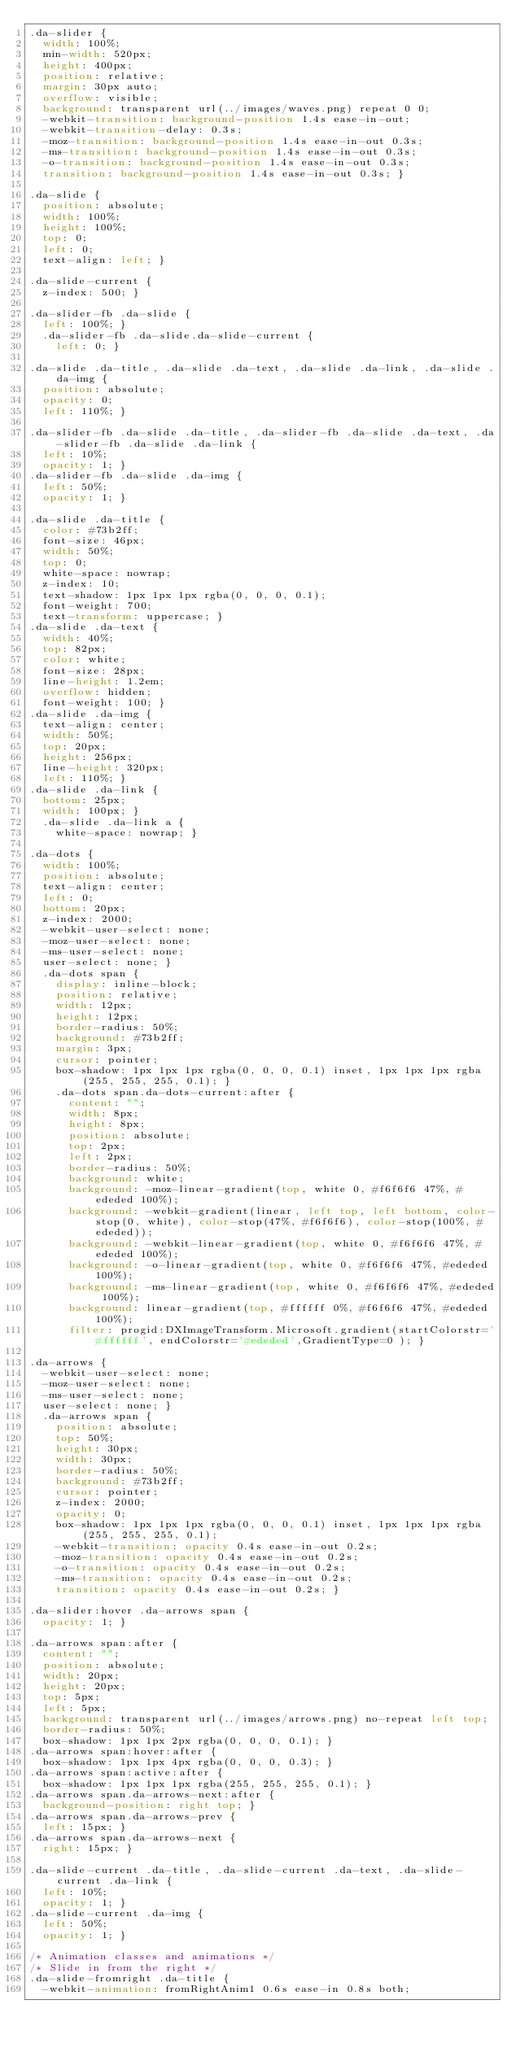<code> <loc_0><loc_0><loc_500><loc_500><_CSS_>.da-slider {
  width: 100%;
  min-width: 520px;
  height: 400px;
  position: relative;
  margin: 30px auto;
  overflow: visible;
  background: transparent url(../images/waves.png) repeat 0 0;
  -webkit-transition: background-position 1.4s ease-in-out;
  -webkit-transition-delay: 0.3s;
  -moz-transition: background-position 1.4s ease-in-out 0.3s;
  -ms-transition: background-position 1.4s ease-in-out 0.3s;
  -o-transition: background-position 1.4s ease-in-out 0.3s;
  transition: background-position 1.4s ease-in-out 0.3s; }

.da-slide {
  position: absolute;
  width: 100%;
  height: 100%;
  top: 0;
  left: 0;
  text-align: left; }

.da-slide-current {
  z-index: 500; }

.da-slider-fb .da-slide {
  left: 100%; }
  .da-slider-fb .da-slide.da-slide-current {
    left: 0; }

.da-slide .da-title, .da-slide .da-text, .da-slide .da-link, .da-slide .da-img {
  position: absolute;
  opacity: 0;
  left: 110%; }

.da-slider-fb .da-slide .da-title, .da-slider-fb .da-slide .da-text, .da-slider-fb .da-slide .da-link {
  left: 10%;
  opacity: 1; }
.da-slider-fb .da-slide .da-img {
  left: 50%;
  opacity: 1; }

.da-slide .da-title {
  color: #73b2ff;
  font-size: 46px;
  width: 50%;
  top: 0;
  white-space: nowrap;
  z-index: 10;
  text-shadow: 1px 1px 1px rgba(0, 0, 0, 0.1);
  font-weight: 700;
  text-transform: uppercase; }
.da-slide .da-text {
  width: 40%;
  top: 82px;
  color: white;
  font-size: 28px;
  line-height: 1.2em;
  overflow: hidden;
  font-weight: 100; }
.da-slide .da-img {
  text-align: center;
  width: 50%;
  top: 20px;
  height: 256px;
  line-height: 320px;
  left: 110%; }
.da-slide .da-link {
  bottom: 25px;
  width: 100px; }
  .da-slide .da-link a {
    white-space: nowrap; }

.da-dots {
  width: 100%;
  position: absolute;
  text-align: center;
  left: 0;
  bottom: 20px;
  z-index: 2000;
  -webkit-user-select: none;
  -moz-user-select: none;
  -ms-user-select: none;
  user-select: none; }
  .da-dots span {
    display: inline-block;
    position: relative;
    width: 12px;
    height: 12px;
    border-radius: 50%;
    background: #73b2ff;
    margin: 3px;
    cursor: pointer;
    box-shadow: 1px 1px 1px rgba(0, 0, 0, 0.1) inset, 1px 1px 1px rgba(255, 255, 255, 0.1); }
    .da-dots span.da-dots-current:after {
      content: "";
      width: 8px;
      height: 8px;
      position: absolute;
      top: 2px;
      left: 2px;
      border-radius: 50%;
      background: white;
      background: -moz-linear-gradient(top, white 0, #f6f6f6 47%, #ededed 100%);
      background: -webkit-gradient(linear, left top, left bottom, color-stop(0, white), color-stop(47%, #f6f6f6), color-stop(100%, #ededed));
      background: -webkit-linear-gradient(top, white 0, #f6f6f6 47%, #ededed 100%);
      background: -o-linear-gradient(top, white 0, #f6f6f6 47%, #ededed 100%);
      background: -ms-linear-gradient(top, white 0, #f6f6f6 47%, #ededed 100%);
      background: linear-gradient(top, #ffffff 0%, #f6f6f6 47%, #ededed 100%);
      filter: progid:DXImageTransform.Microsoft.gradient(startColorstr='#ffffff', endColorstr='#ededed',GradientType=0 ); }

.da-arrows {
  -webkit-user-select: none;
  -moz-user-select: none;
  -ms-user-select: none;
  user-select: none; }
  .da-arrows span {
    position: absolute;
    top: 50%;
    height: 30px;
    width: 30px;
    border-radius: 50%;
    background: #73b2ff;
    cursor: pointer;
    z-index: 2000;
    opacity: 0;
    box-shadow: 1px 1px 1px rgba(0, 0, 0, 0.1) inset, 1px 1px 1px rgba(255, 255, 255, 0.1);
    -webkit-transition: opacity 0.4s ease-in-out 0.2s;
    -moz-transition: opacity 0.4s ease-in-out 0.2s;
    -o-transition: opacity 0.4s ease-in-out 0.2s;
    -ms-transition: opacity 0.4s ease-in-out 0.2s;
    transition: opacity 0.4s ease-in-out 0.2s; }

.da-slider:hover .da-arrows span {
  opacity: 1; }

.da-arrows span:after {
  content: "";
  position: absolute;
  width: 20px;
  height: 20px;
  top: 5px;
  left: 5px;
  background: transparent url(../images/arrows.png) no-repeat left top;
  border-radius: 50%;
  box-shadow: 1px 1px 2px rgba(0, 0, 0, 0.1); }
.da-arrows span:hover:after {
  box-shadow: 1px 1px 4px rgba(0, 0, 0, 0.3); }
.da-arrows span:active:after {
  box-shadow: 1px 1px 1px rgba(255, 255, 255, 0.1); }
.da-arrows span.da-arrows-next:after {
  background-position: right top; }
.da-arrows span.da-arrows-prev {
  left: 15px; }
.da-arrows span.da-arrows-next {
  right: 15px; }

.da-slide-current .da-title, .da-slide-current .da-text, .da-slide-current .da-link {
  left: 10%;
  opacity: 1; }
.da-slide-current .da-img {
  left: 50%;
  opacity: 1; }

/* Animation classes and animations */
/* Slide in from the right */
.da-slide-fromright .da-title {
  -webkit-animation: fromRightAnim1 0.6s ease-in 0.8s both;</code> 